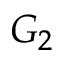<formula> <loc_0><loc_0><loc_500><loc_500>G _ { 2 }</formula> 